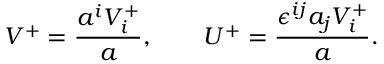Convert formula to latex. <formula><loc_0><loc_0><loc_500><loc_500>V ^ { + } = \frac { a ^ { i } V _ { i } ^ { + } } a , \quad U ^ { + } = \frac { \epsilon ^ { i j } a _ { j } V _ { i } ^ { + } } a .</formula> 